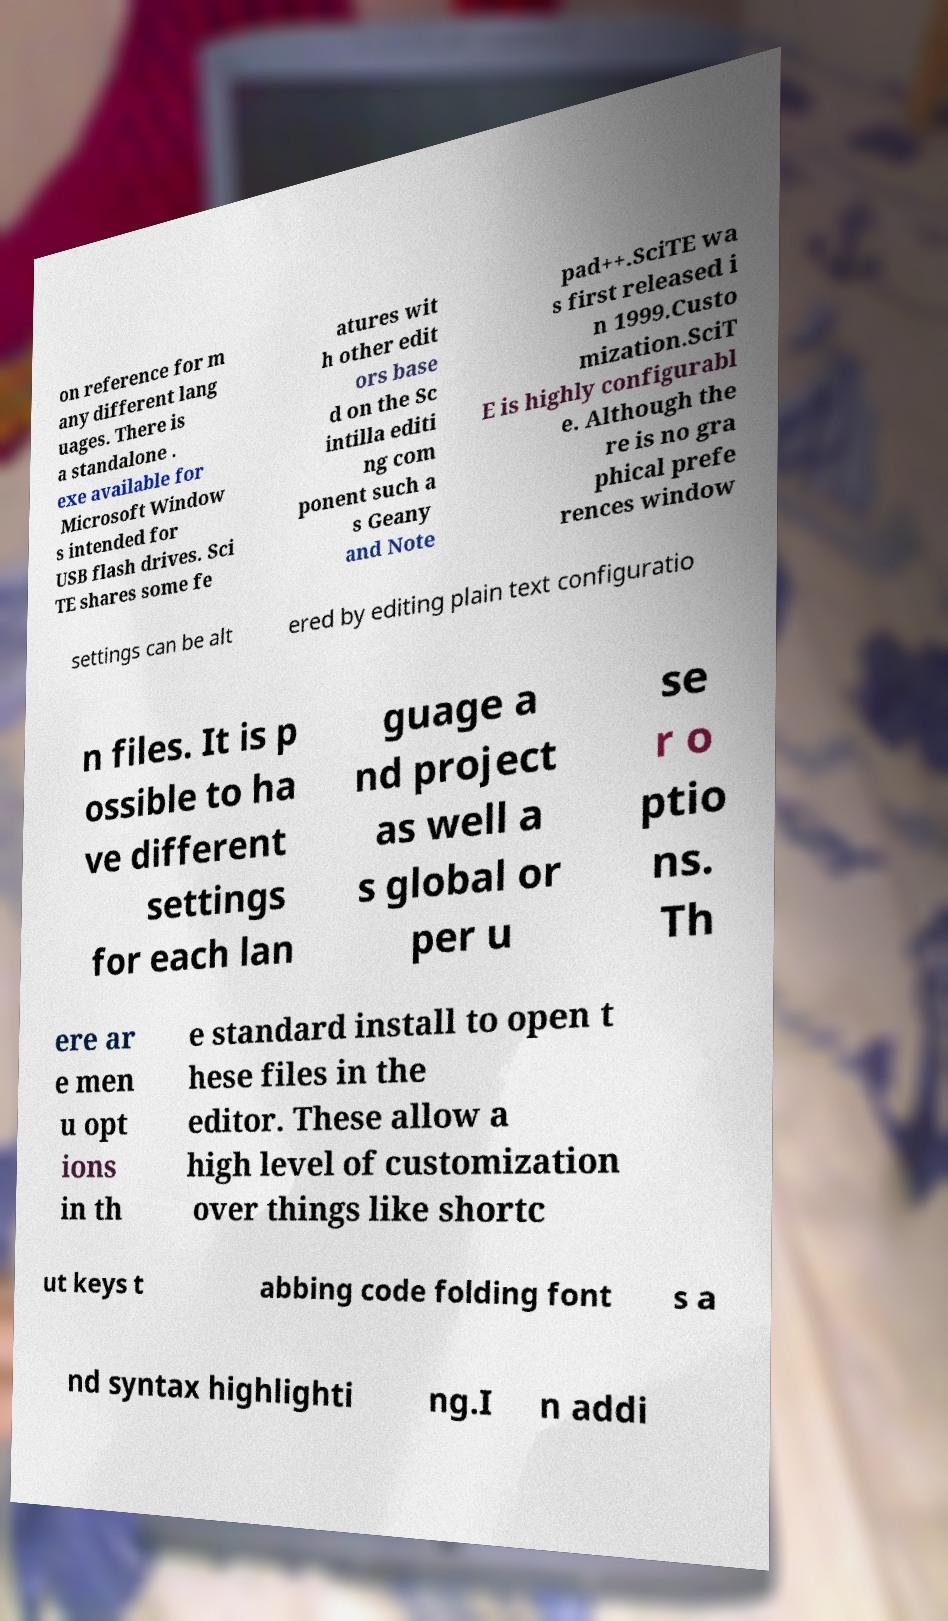Please identify and transcribe the text found in this image. on reference for m any different lang uages. There is a standalone . exe available for Microsoft Window s intended for USB flash drives. Sci TE shares some fe atures wit h other edit ors base d on the Sc intilla editi ng com ponent such a s Geany and Note pad++.SciTE wa s first released i n 1999.Custo mization.SciT E is highly configurabl e. Although the re is no gra phical prefe rences window settings can be alt ered by editing plain text configuratio n files. It is p ossible to ha ve different settings for each lan guage a nd project as well a s global or per u se r o ptio ns. Th ere ar e men u opt ions in th e standard install to open t hese files in the editor. These allow a high level of customization over things like shortc ut keys t abbing code folding font s a nd syntax highlighti ng.I n addi 